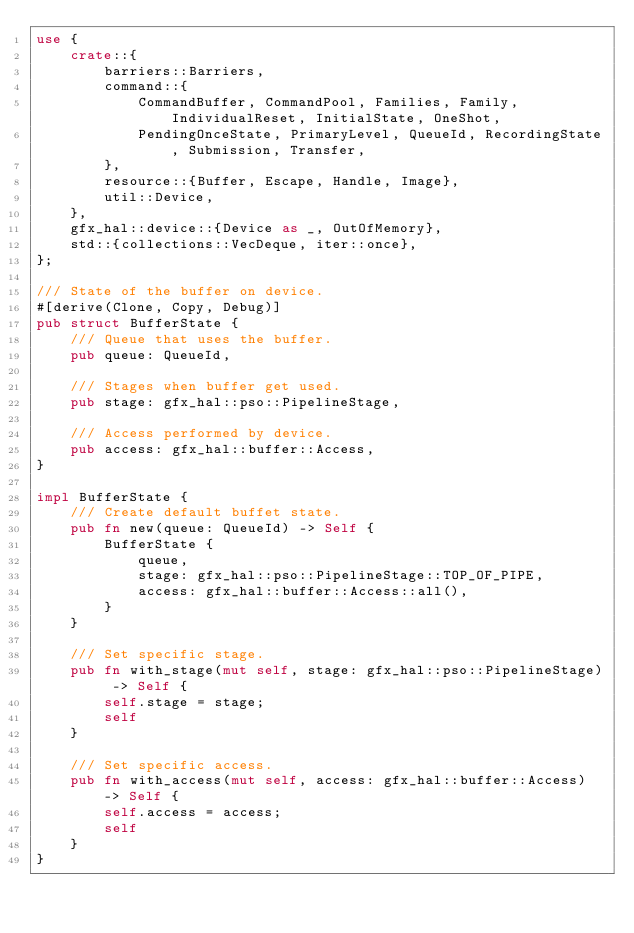Convert code to text. <code><loc_0><loc_0><loc_500><loc_500><_Rust_>use {
    crate::{
        barriers::Barriers,
        command::{
            CommandBuffer, CommandPool, Families, Family, IndividualReset, InitialState, OneShot,
            PendingOnceState, PrimaryLevel, QueueId, RecordingState, Submission, Transfer,
        },
        resource::{Buffer, Escape, Handle, Image},
        util::Device,
    },
    gfx_hal::device::{Device as _, OutOfMemory},
    std::{collections::VecDeque, iter::once},
};

/// State of the buffer on device.
#[derive(Clone, Copy, Debug)]
pub struct BufferState {
    /// Queue that uses the buffer.
    pub queue: QueueId,

    /// Stages when buffer get used.
    pub stage: gfx_hal::pso::PipelineStage,

    /// Access performed by device.
    pub access: gfx_hal::buffer::Access,
}

impl BufferState {
    /// Create default buffet state.
    pub fn new(queue: QueueId) -> Self {
        BufferState {
            queue,
            stage: gfx_hal::pso::PipelineStage::TOP_OF_PIPE,
            access: gfx_hal::buffer::Access::all(),
        }
    }

    /// Set specific stage.
    pub fn with_stage(mut self, stage: gfx_hal::pso::PipelineStage) -> Self {
        self.stage = stage;
        self
    }

    /// Set specific access.
    pub fn with_access(mut self, access: gfx_hal::buffer::Access) -> Self {
        self.access = access;
        self
    }
}
</code> 